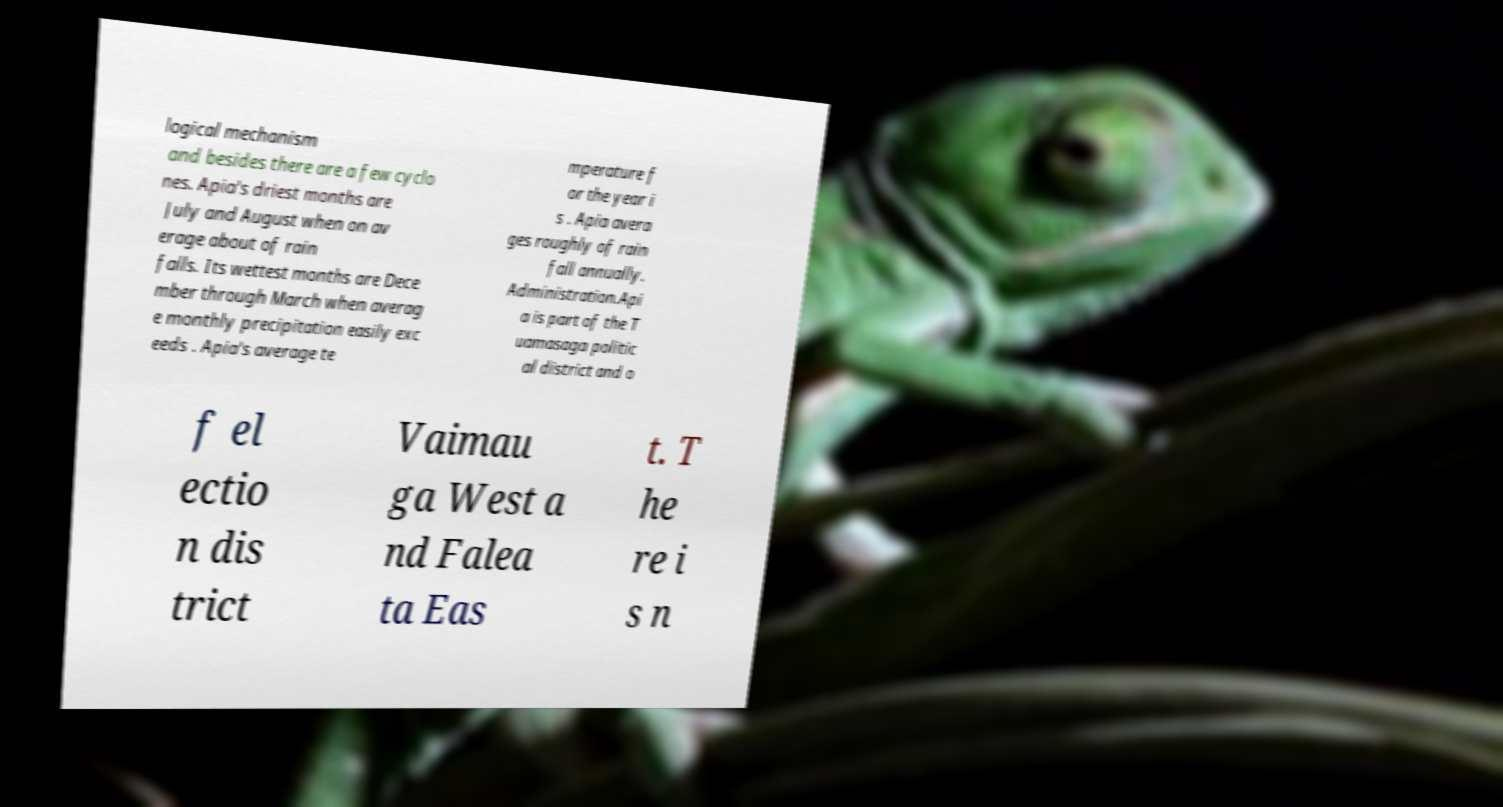Could you extract and type out the text from this image? logical mechanism and besides there are a few cyclo nes. Apia's driest months are July and August when on av erage about of rain falls. Its wettest months are Dece mber through March when averag e monthly precipitation easily exc eeds . Apia's average te mperature f or the year i s . Apia avera ges roughly of rain fall annually. Administration.Api a is part of the T uamasaga politic al district and o f el ectio n dis trict Vaimau ga West a nd Falea ta Eas t. T he re i s n 